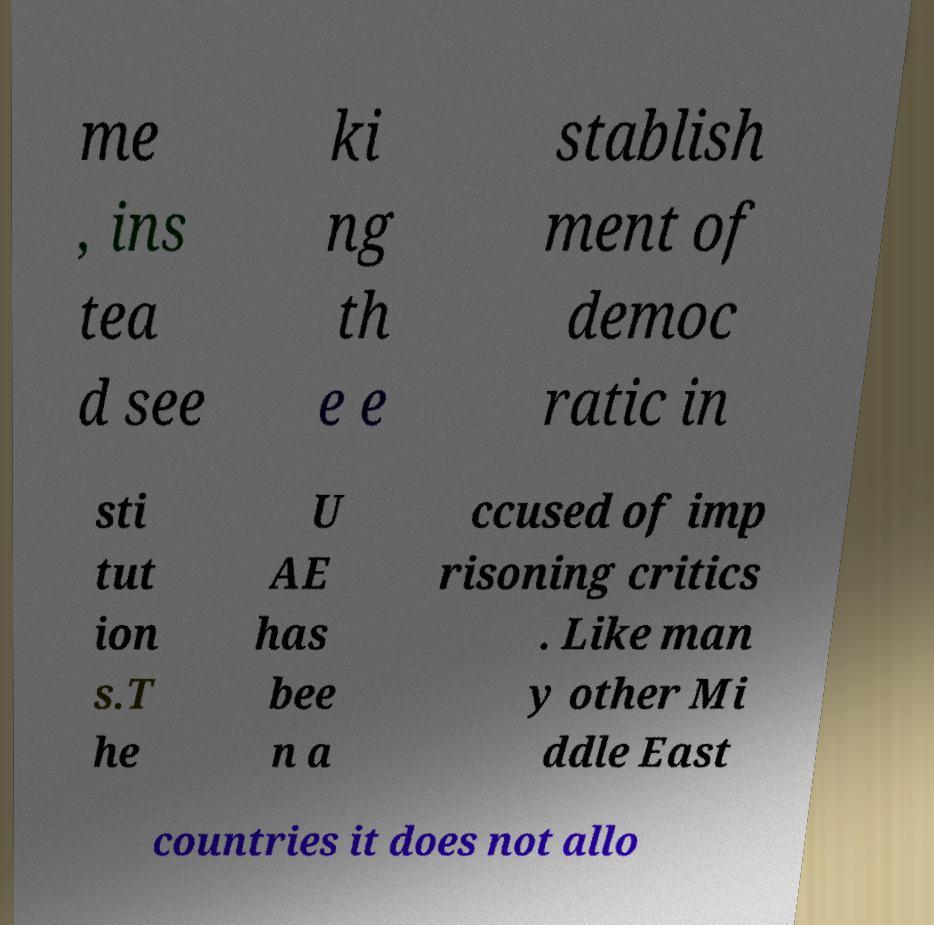I need the written content from this picture converted into text. Can you do that? me , ins tea d see ki ng th e e stablish ment of democ ratic in sti tut ion s.T he U AE has bee n a ccused of imp risoning critics . Like man y other Mi ddle East countries it does not allo 